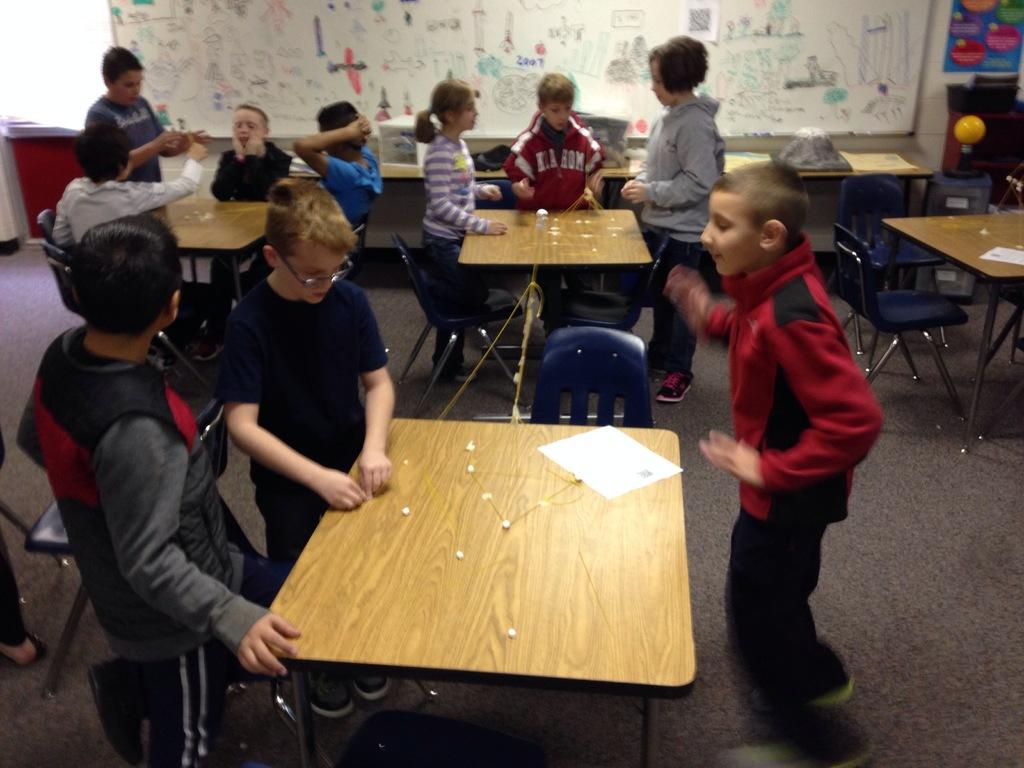What is the main subject of the image? The main subject of the image is a group of kids. What are the kids doing in the image? The kids are playing in the image. How are the kids positioned in the image? Some kids are seated on chairs, while others are standing. What is present in front of the kids? There is a table in front of the kids. What can be seen in the background of the image? There is a notice board in the background of the image. How long does it take for the kids to pay attention to the shoes in the image? There are no shoes present in the image, so it is not possible to determine how long it takes for the kids to pay attention to them. 